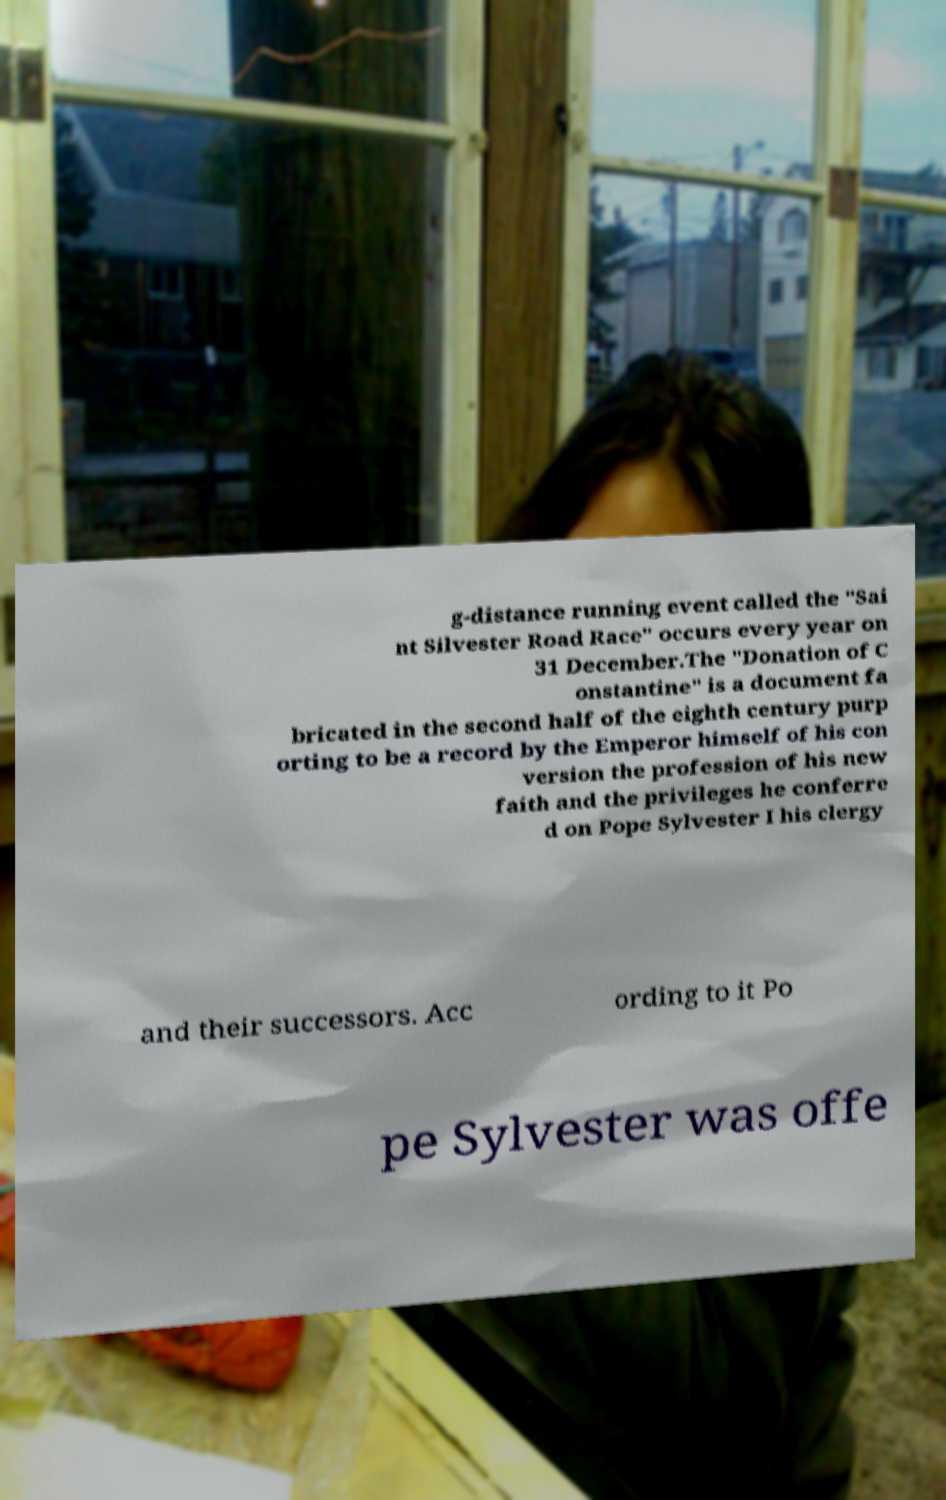Can you accurately transcribe the text from the provided image for me? g-distance running event called the "Sai nt Silvester Road Race" occurs every year on 31 December.The "Donation of C onstantine" is a document fa bricated in the second half of the eighth century purp orting to be a record by the Emperor himself of his con version the profession of his new faith and the privileges he conferre d on Pope Sylvester I his clergy and their successors. Acc ording to it Po pe Sylvester was offe 